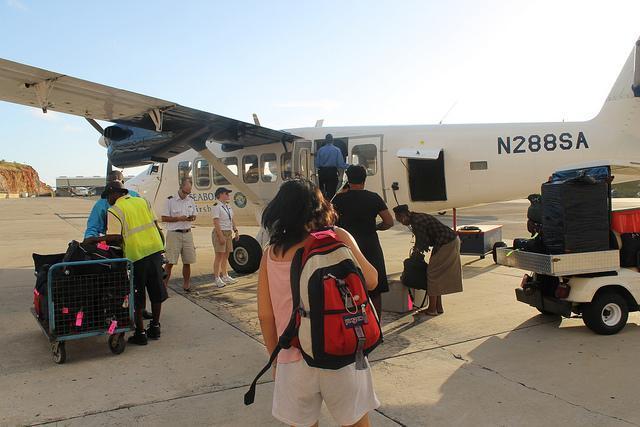Where do the people wearing white shirts work?
Answer the question by selecting the correct answer among the 4 following choices.
Options: Government, airplane, sewer, golf course. Airplane. 